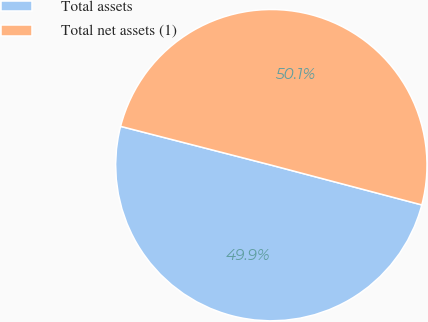Convert chart. <chart><loc_0><loc_0><loc_500><loc_500><pie_chart><fcel>Total assets<fcel>Total net assets (1)<nl><fcel>49.9%<fcel>50.1%<nl></chart> 